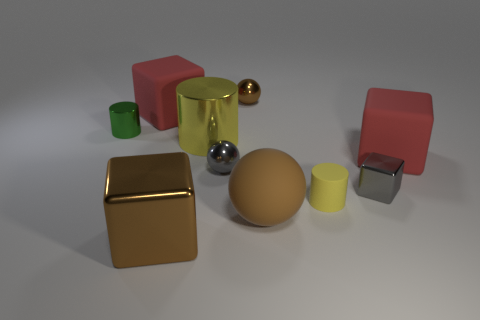Are there the same number of brown matte balls that are left of the big brown metal thing and small purple rubber cylinders?
Your answer should be very brief. Yes. Do the small cylinder that is left of the large yellow object and the big red thing that is to the left of the small yellow rubber object have the same material?
Give a very brief answer. No. How many objects are yellow spheres or rubber blocks that are left of the tiny gray block?
Provide a short and direct response. 1. Is there another tiny green object of the same shape as the tiny matte object?
Your answer should be very brief. Yes. There is a brown object behind the big red block that is behind the tiny cylinder on the left side of the large rubber sphere; what is its size?
Ensure brevity in your answer.  Small. Is the number of red objects on the right side of the tiny brown metal sphere the same as the number of yellow cylinders that are in front of the small yellow thing?
Your response must be concise. No. There is a green cylinder that is made of the same material as the big yellow cylinder; what size is it?
Give a very brief answer. Small. What is the color of the tiny block?
Your answer should be compact. Gray. What number of shiny things have the same color as the rubber cylinder?
Your answer should be very brief. 1. There is a cube that is the same size as the brown metal sphere; what is it made of?
Offer a very short reply. Metal. 